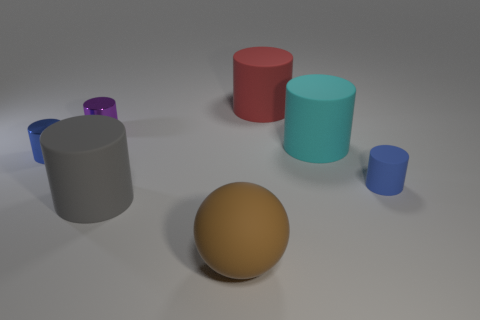What size is the metal cylinder that is the same color as the small rubber thing?
Provide a succinct answer. Small. The small matte object is what shape?
Provide a short and direct response. Cylinder. Do the tiny rubber thing and the large matte cylinder that is behind the large cyan thing have the same color?
Ensure brevity in your answer.  No. Are there an equal number of blue metal cylinders right of the sphere and brown spheres?
Ensure brevity in your answer.  No. How many blue shiny cylinders are the same size as the brown sphere?
Provide a short and direct response. 0. There is a small object that is the same color as the small rubber cylinder; what shape is it?
Your answer should be compact. Cylinder. Are any green matte cubes visible?
Offer a terse response. No. Is the shape of the large rubber object behind the tiny purple shiny cylinder the same as the large cyan thing on the right side of the big brown rubber sphere?
Offer a very short reply. Yes. How many large things are purple shiny things or brown metal blocks?
Your answer should be compact. 0. What is the shape of the tiny object that is the same material as the purple cylinder?
Give a very brief answer. Cylinder. 